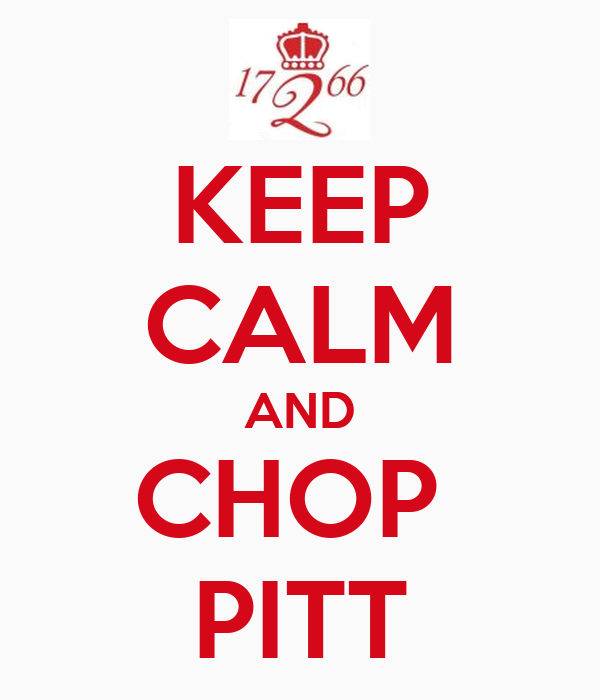Considering the design elements used in this image, what historical or cultural reference is being made, and how does the emblem contribute to the message of the image? The design elements in this image are reminiscent of the famous "Keep Calm and Carry On" poster, which was produced by the British government in 1939 during the outbreak of World War II as a means to bolster morale. The poster’s distinctive typeface and layout have become iconic, often parodied or adapted for modern purposes. In this image, the phrase "Keep Calm and Chop Pitt" overlays a similar structure, replacing 'Carry On' with what seems to be a directive or slogan potentially aimed at a specific community or activity—likely referencing the act of chopping wood or a rival entity named Pitt. Additionally, the crown emblem with the year "1766" may suggest a significant historical event or institution from that time, perhaps a founding year or commemorative date, lending the message a sense of tradition and authority. This blend of historical visual elements with contemporary messaging creates an emotional and cultural resonance, urging viewers to remain composed and continue action in a context defined by both current relevance and historical depth. 